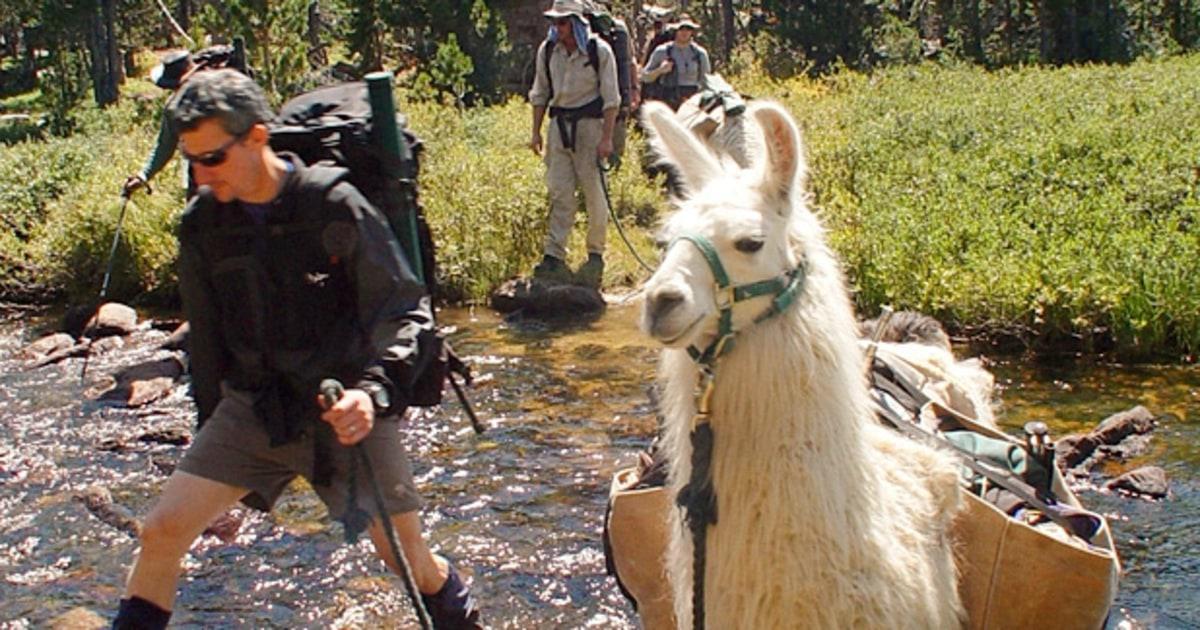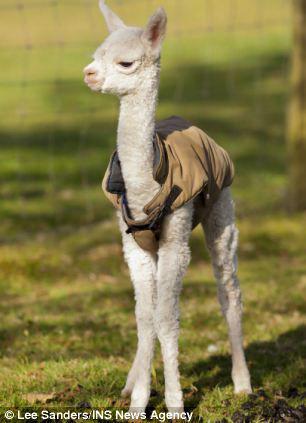The first image is the image on the left, the second image is the image on the right. Given the left and right images, does the statement "In at least one image there is a single baby alpaca with its body facing forward." hold true? Answer yes or no. Yes. The first image is the image on the left, the second image is the image on the right. Given the left and right images, does the statement "The left image shows a man in shorts and sunglasses standing by a white llama wearing a pack, and the right image shows a forward-turned llama wearing some type of attire." hold true? Answer yes or no. Yes. 